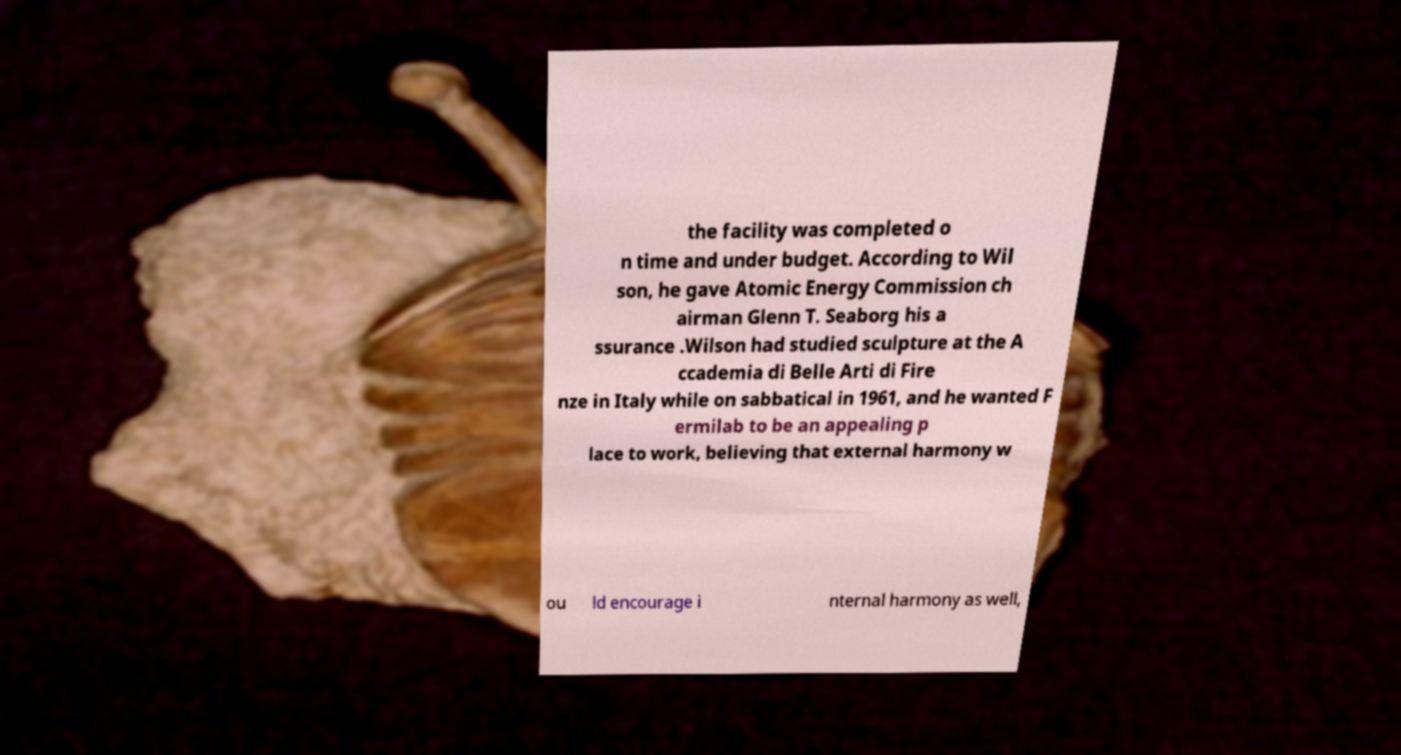For documentation purposes, I need the text within this image transcribed. Could you provide that? the facility was completed o n time and under budget. According to Wil son, he gave Atomic Energy Commission ch airman Glenn T. Seaborg his a ssurance .Wilson had studied sculpture at the A ccademia di Belle Arti di Fire nze in Italy while on sabbatical in 1961, and he wanted F ermilab to be an appealing p lace to work, believing that external harmony w ou ld encourage i nternal harmony as well, 